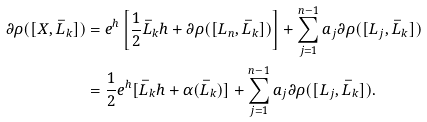<formula> <loc_0><loc_0><loc_500><loc_500>\partial \rho ( [ X , \bar { L } _ { k } ] ) & = e ^ { h } \left [ \frac { 1 } { 2 } \bar { L } _ { k } h + \partial \rho ( [ L _ { n } , \bar { L } _ { k } ] ) \right ] + \sum ^ { n - 1 } _ { j = 1 } a _ { j } \partial \rho ( [ L _ { j } , \bar { L } _ { k } ] ) \\ & = \frac { 1 } { 2 } e ^ { h } [ \bar { L } _ { k } h + \alpha ( \bar { L } _ { k } ) ] + \sum ^ { n - 1 } _ { j = 1 } a _ { j } \partial \rho ( [ L _ { j } , \bar { L } _ { k } ] ) .</formula> 